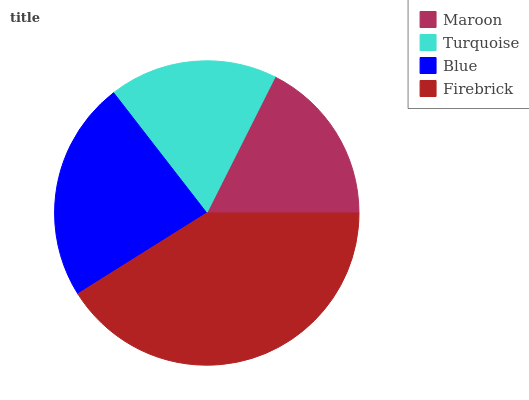Is Maroon the minimum?
Answer yes or no. Yes. Is Firebrick the maximum?
Answer yes or no. Yes. Is Turquoise the minimum?
Answer yes or no. No. Is Turquoise the maximum?
Answer yes or no. No. Is Turquoise greater than Maroon?
Answer yes or no. Yes. Is Maroon less than Turquoise?
Answer yes or no. Yes. Is Maroon greater than Turquoise?
Answer yes or no. No. Is Turquoise less than Maroon?
Answer yes or no. No. Is Blue the high median?
Answer yes or no. Yes. Is Turquoise the low median?
Answer yes or no. Yes. Is Firebrick the high median?
Answer yes or no. No. Is Maroon the low median?
Answer yes or no. No. 